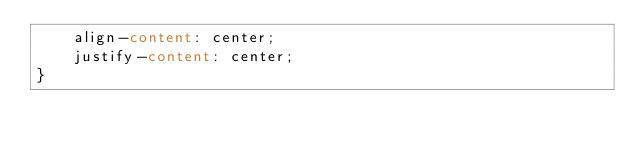<code> <loc_0><loc_0><loc_500><loc_500><_CSS_>    align-content: center;
    justify-content: center;
}</code> 